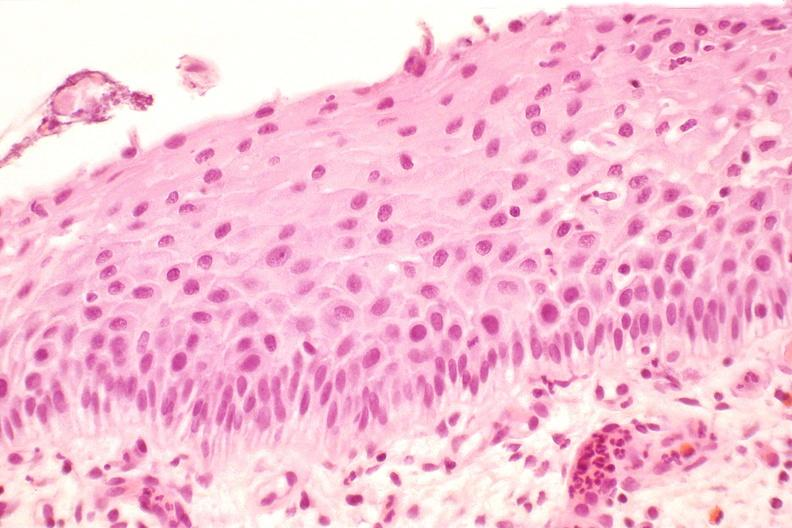what does this image show?
Answer the question using a single word or phrase. Cervix 